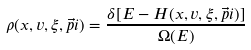Convert formula to latex. <formula><loc_0><loc_0><loc_500><loc_500>\rho ( x , v , \xi , \vec { p } i ) = \frac { \delta [ E - H ( x , v , \xi , \vec { p } i ) ] } { \Omega ( E ) }</formula> 